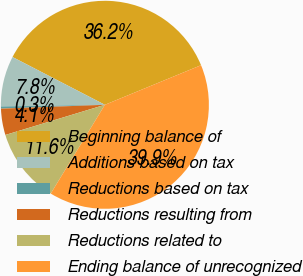<chart> <loc_0><loc_0><loc_500><loc_500><pie_chart><fcel>Beginning balance of<fcel>Additions based on tax<fcel>Reductions based on tax<fcel>Reductions resulting from<fcel>Reductions related to<fcel>Ending balance of unrecognized<nl><fcel>36.19%<fcel>7.85%<fcel>0.34%<fcel>4.09%<fcel>11.6%<fcel>39.94%<nl></chart> 